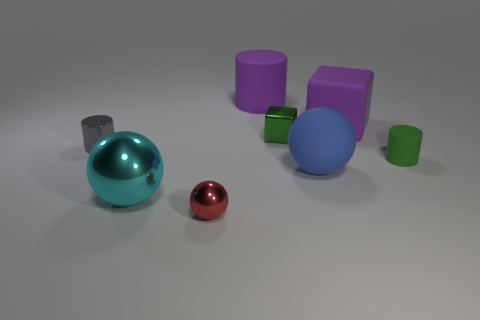What number of spheres are either cyan metal objects or tiny matte objects?
Give a very brief answer. 1. There is another shiny object that is the same shape as the red metal thing; what is its size?
Make the answer very short. Large. What number of large brown shiny cylinders are there?
Provide a short and direct response. 0. There is a small green shiny object; is it the same shape as the tiny thing that is to the left of the tiny red sphere?
Your answer should be very brief. No. There is a blue rubber ball in front of the gray cylinder; what size is it?
Your answer should be compact. Large. What material is the big blue object?
Provide a short and direct response. Rubber. There is a rubber object in front of the tiny green cylinder; is it the same shape as the green rubber thing?
Keep it short and to the point. No. The thing that is the same color as the rubber block is what size?
Ensure brevity in your answer.  Large. Is there a gray shiny cylinder that has the same size as the red sphere?
Your answer should be very brief. Yes. Are there any matte things behind the small thing to the left of the ball left of the red sphere?
Give a very brief answer. Yes. 